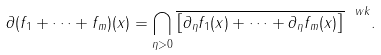Convert formula to latex. <formula><loc_0><loc_0><loc_500><loc_500>\partial ( f _ { 1 } + \cdots + f _ { m } ) ( x ) = \bigcap _ { \eta > 0 } \overline { \left [ \partial _ { \eta } f _ { 1 } ( x ) + \cdots + \partial _ { \eta } f _ { m } ( x ) \right ] } ^ { \ w k } .</formula> 